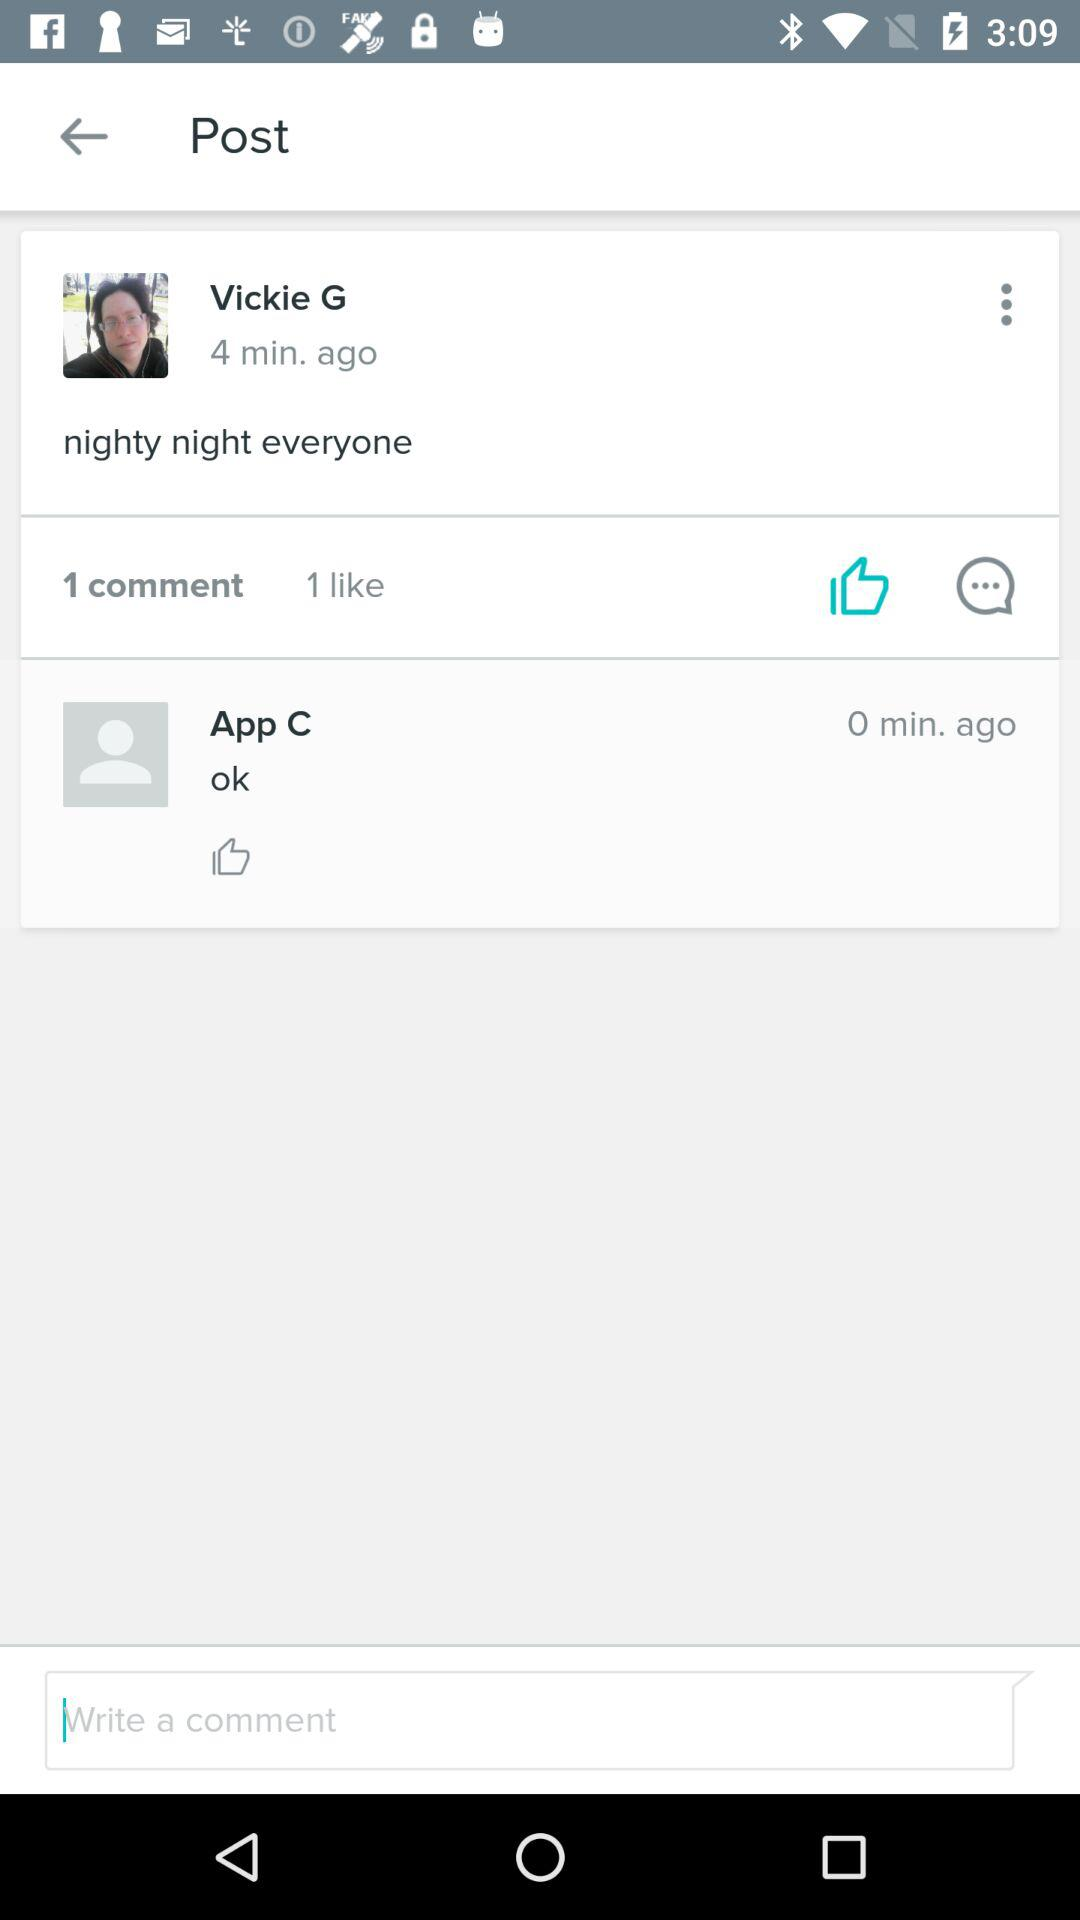When was the post posted? The post was posted 4 minutes ago. 